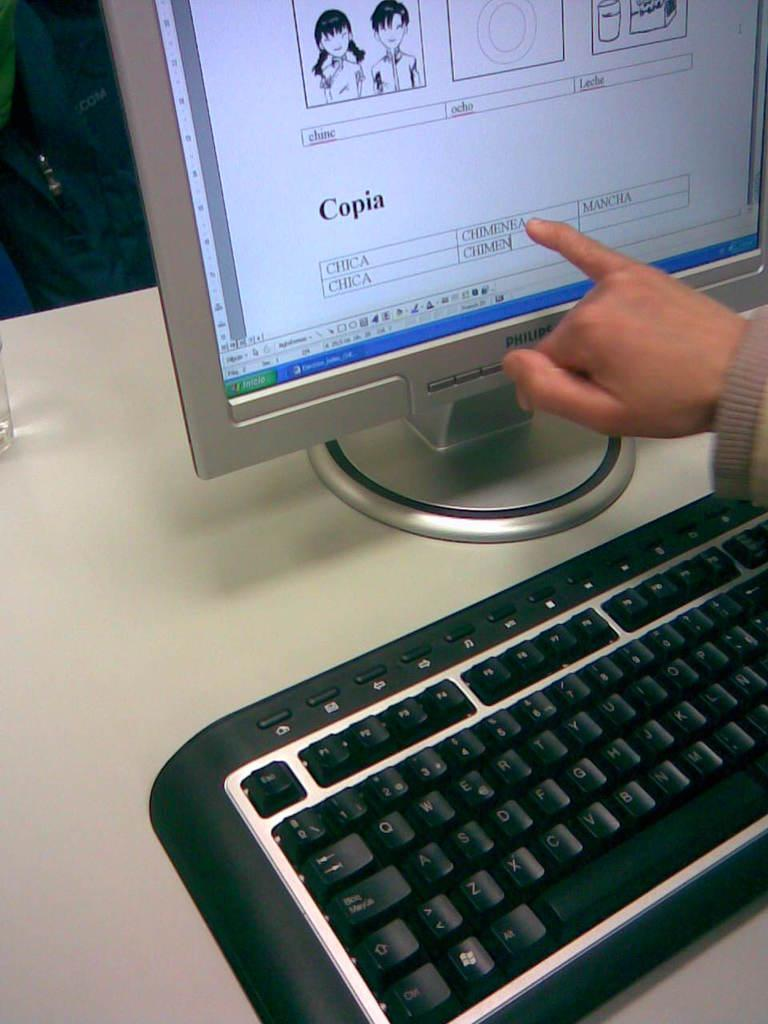<image>
Share a concise interpretation of the image provided. Someone points to the computer monitor that has "copia" on it. 